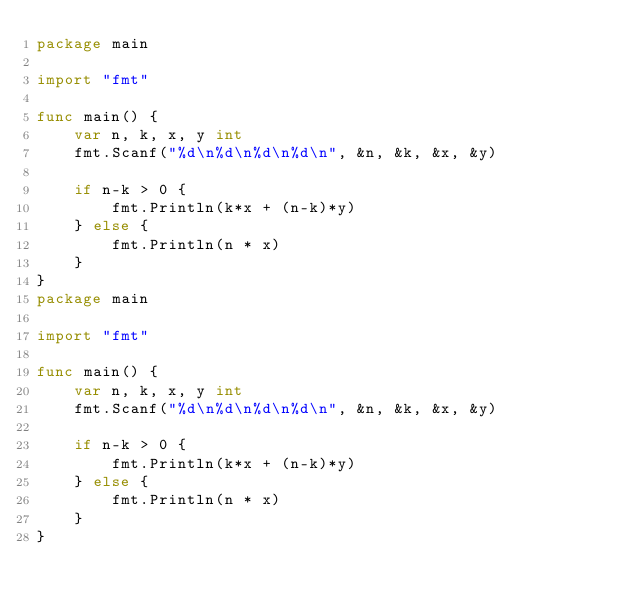Convert code to text. <code><loc_0><loc_0><loc_500><loc_500><_Go_>package main

import "fmt"

func main() {
	var n, k, x, y int
	fmt.Scanf("%d\n%d\n%d\n%d\n", &n, &k, &x, &y)

	if n-k > 0 {
		fmt.Println(k*x + (n-k)*y)
	} else {
		fmt.Println(n * x)
	}
}
package main

import "fmt"

func main() {
	var n, k, x, y int
	fmt.Scanf("%d\n%d\n%d\n%d\n", &n, &k, &x, &y)

	if n-k > 0 {
		fmt.Println(k*x + (n-k)*y)
	} else {
		fmt.Println(n * x)
	}
}
</code> 